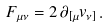Convert formula to latex. <formula><loc_0><loc_0><loc_500><loc_500>F _ { \mu \nu } = 2 \, \partial _ { [ \mu } v _ { \nu ] } \, .</formula> 